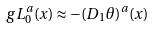Convert formula to latex. <formula><loc_0><loc_0><loc_500><loc_500>g L _ { 0 } ^ { a } ( x ) \approx - { ( D _ { 1 } \theta ) } ^ { a } ( x )</formula> 